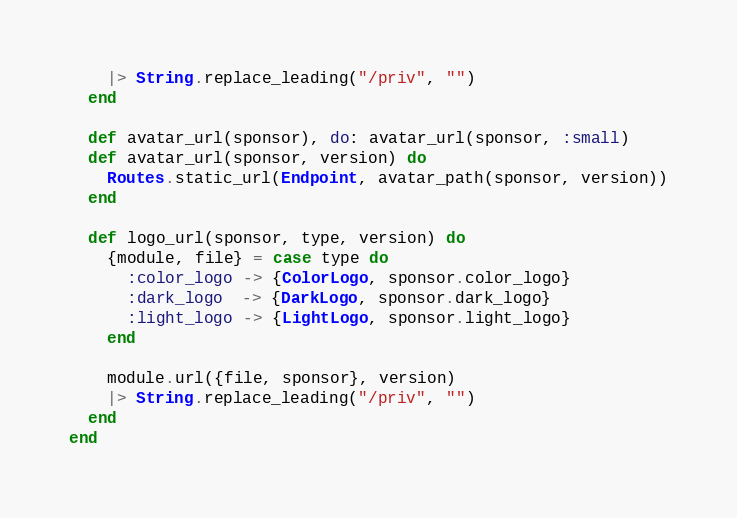Convert code to text. <code><loc_0><loc_0><loc_500><loc_500><_Elixir_>    |> String.replace_leading("/priv", "")
  end

  def avatar_url(sponsor), do: avatar_url(sponsor, :small)
  def avatar_url(sponsor, version) do
    Routes.static_url(Endpoint, avatar_path(sponsor, version))
  end

  def logo_url(sponsor, type, version) do
    {module, file} = case type do
      :color_logo -> {ColorLogo, sponsor.color_logo}
      :dark_logo  -> {DarkLogo, sponsor.dark_logo}
      :light_logo -> {LightLogo, sponsor.light_logo}
    end

    module.url({file, sponsor}, version)
    |> String.replace_leading("/priv", "")
  end
end
</code> 